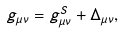Convert formula to latex. <formula><loc_0><loc_0><loc_500><loc_500>g _ { \mu \nu } = g _ { \mu \nu } ^ { S } + \Delta _ { \mu \nu } ,</formula> 